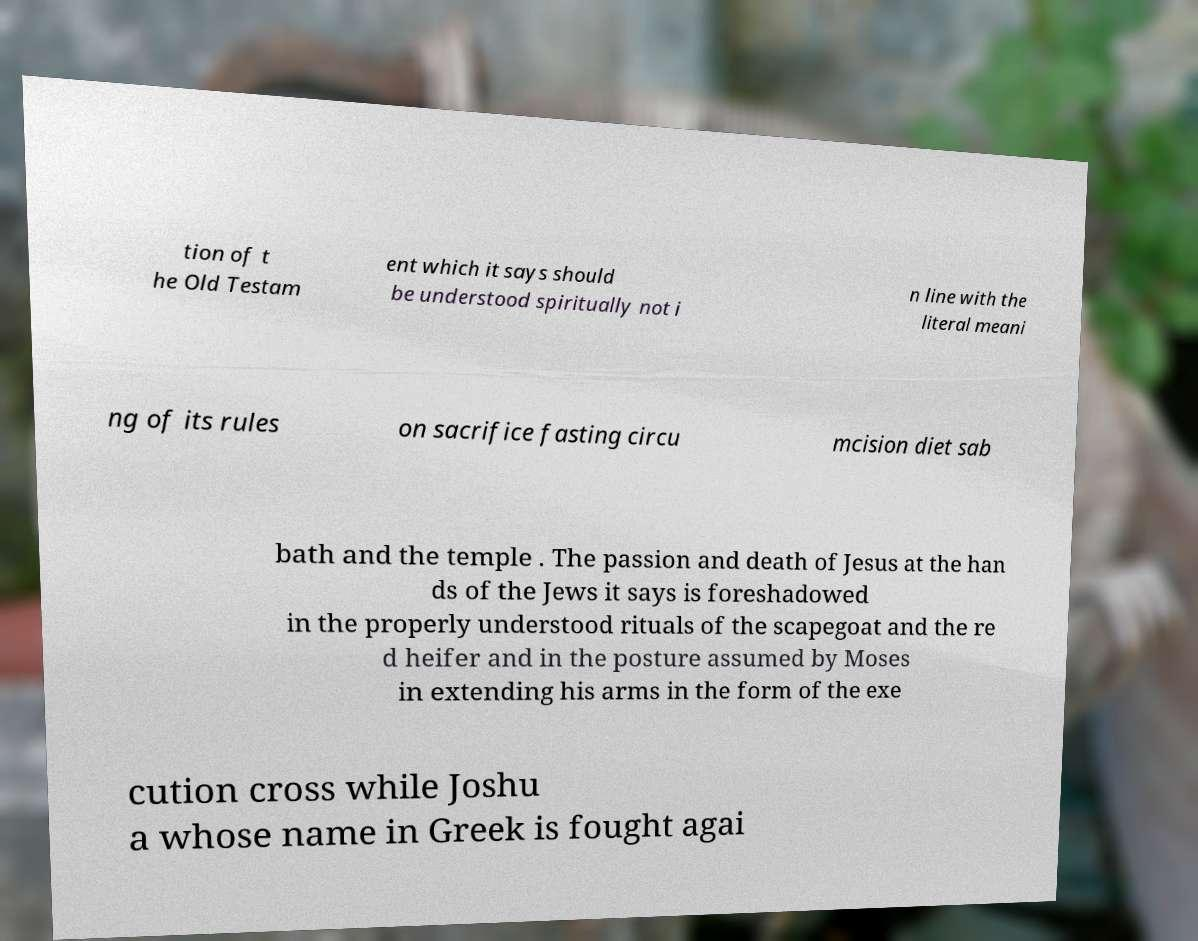Please identify and transcribe the text found in this image. tion of t he Old Testam ent which it says should be understood spiritually not i n line with the literal meani ng of its rules on sacrifice fasting circu mcision diet sab bath and the temple . The passion and death of Jesus at the han ds of the Jews it says is foreshadowed in the properly understood rituals of the scapegoat and the re d heifer and in the posture assumed by Moses in extending his arms in the form of the exe cution cross while Joshu a whose name in Greek is fought agai 